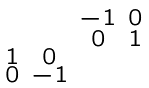<formula> <loc_0><loc_0><loc_500><loc_500>\begin{smallmatrix} & & - 1 & 0 \\ & & 0 & 1 \\ 1 & 0 & & \\ 0 & - 1 & & \end{smallmatrix}</formula> 